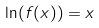Convert formula to latex. <formula><loc_0><loc_0><loc_500><loc_500>\ln ( f ( x ) ) = x</formula> 